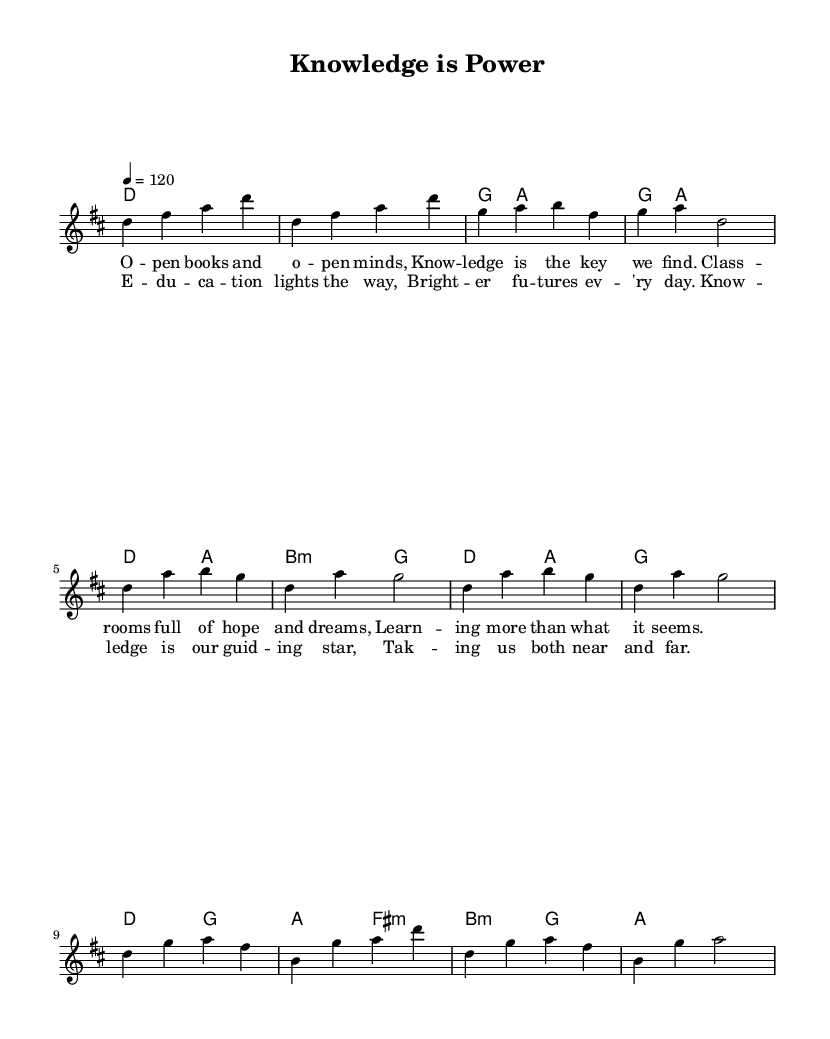What is the key signature of this music? The key signature given in the global setting is D major, which has two sharps (F# and C#).
Answer: D major What is the time signature used in this piece? The time signature is indicated in the global settings as 4/4, meaning there are four beats per measure and the quarter note gets one beat.
Answer: 4/4 What is the tempo marking for this composition? The tempo is noted as 4 = 120, which indicates that the quarter note is played at a speed of 120 beats per minute.
Answer: 120 How many measures are there in the chorus section? The chorus is composed of 4 measures, as can be counted in the notation where each line in the melody corresponds to a single measure.
Answer: 4 What are the lyrics of the first verse? The lyrics for the first verse are displayed in the lyric mode section and read: "Open books and open minds, Knowledge is the key we find. Classrooms full of hope and dreams, Learning more than what it seems."
Answer: "Open books and open minds, Knowledge is the key we find. Classrooms full of hope and dreams, Learning more than what it seems." Identify the first chord in the song. The first chord in the harmonies section under the chord mode is labeled as D, which is indicated by the 'd' in the chord notation.
Answer: D 